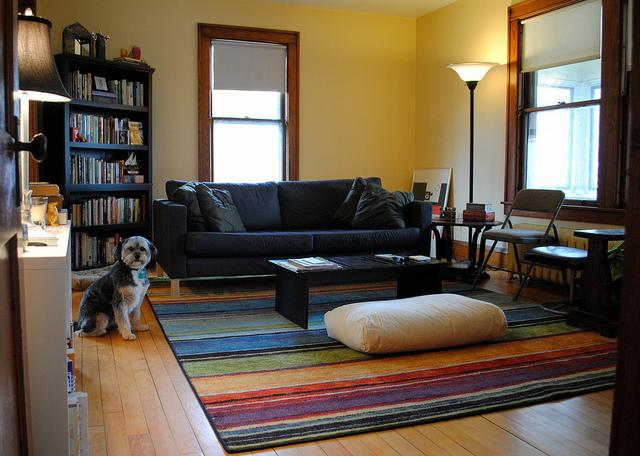What sound does the animal make?

Choices:
A) neigh
B) woof
C) moo
D) meow woof 